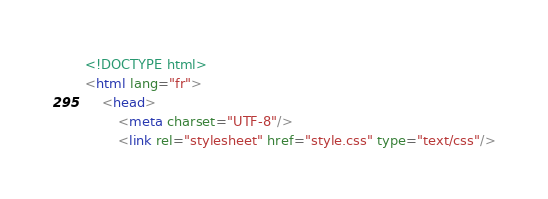Convert code to text. <code><loc_0><loc_0><loc_500><loc_500><_HTML_><!DOCTYPE html>
<html lang="fr">
    <head>
        <meta charset="UTF-8"/>
        <link rel="stylesheet" href="style.css" type="text/css"/></code> 